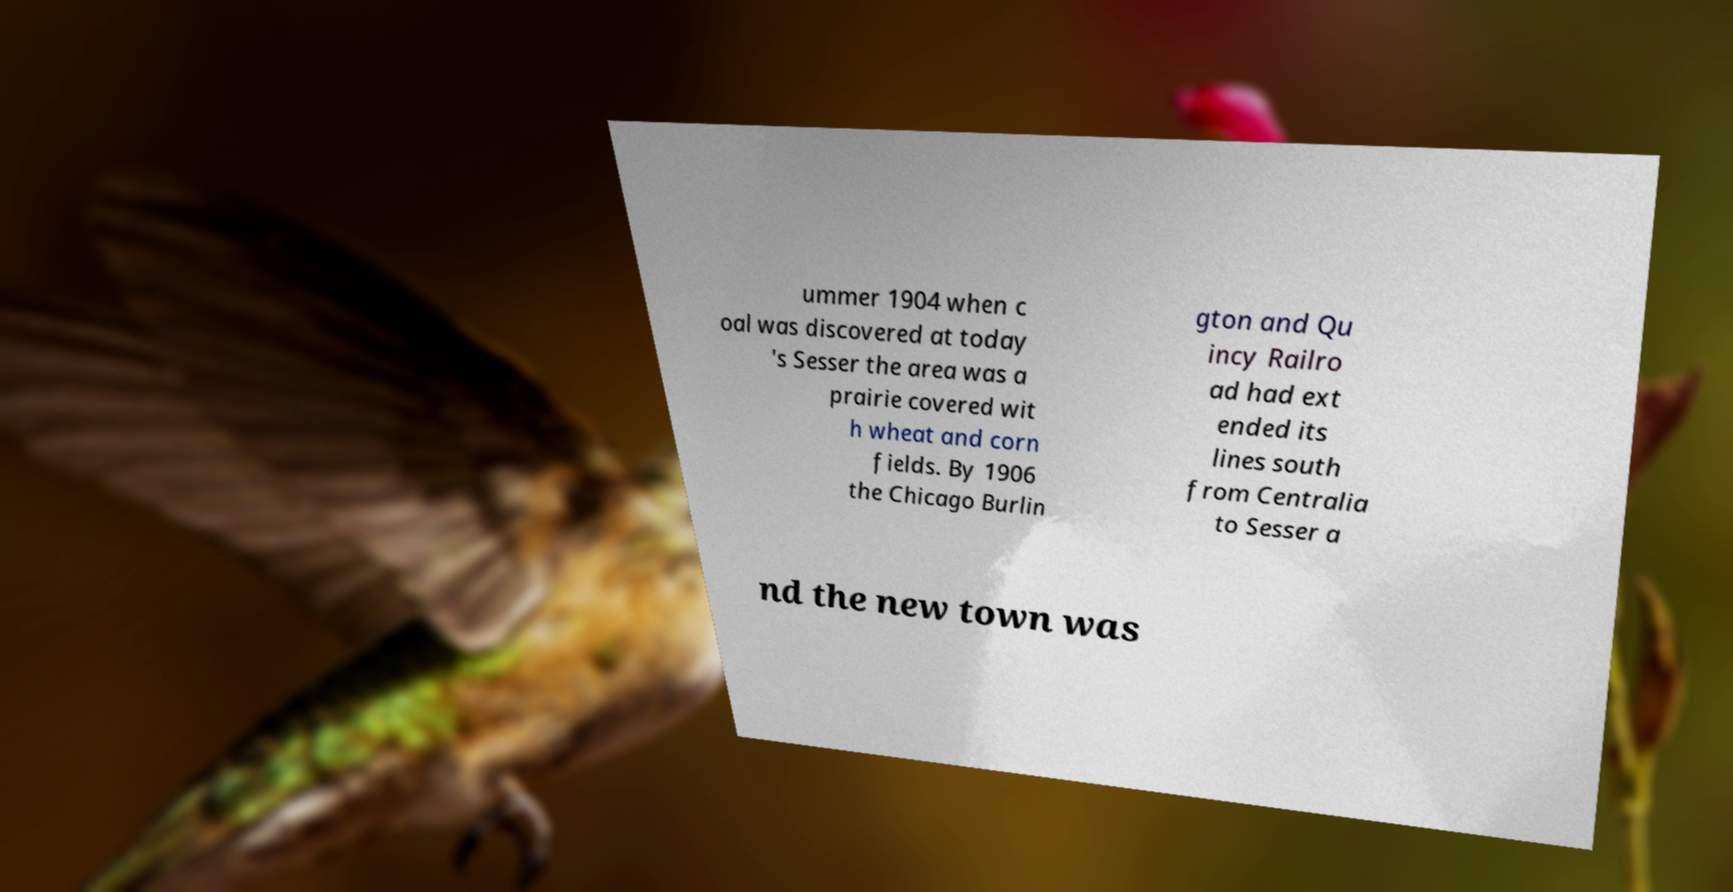Please read and relay the text visible in this image. What does it say? ummer 1904 when c oal was discovered at today 's Sesser the area was a prairie covered wit h wheat and corn fields. By 1906 the Chicago Burlin gton and Qu incy Railro ad had ext ended its lines south from Centralia to Sesser a nd the new town was 